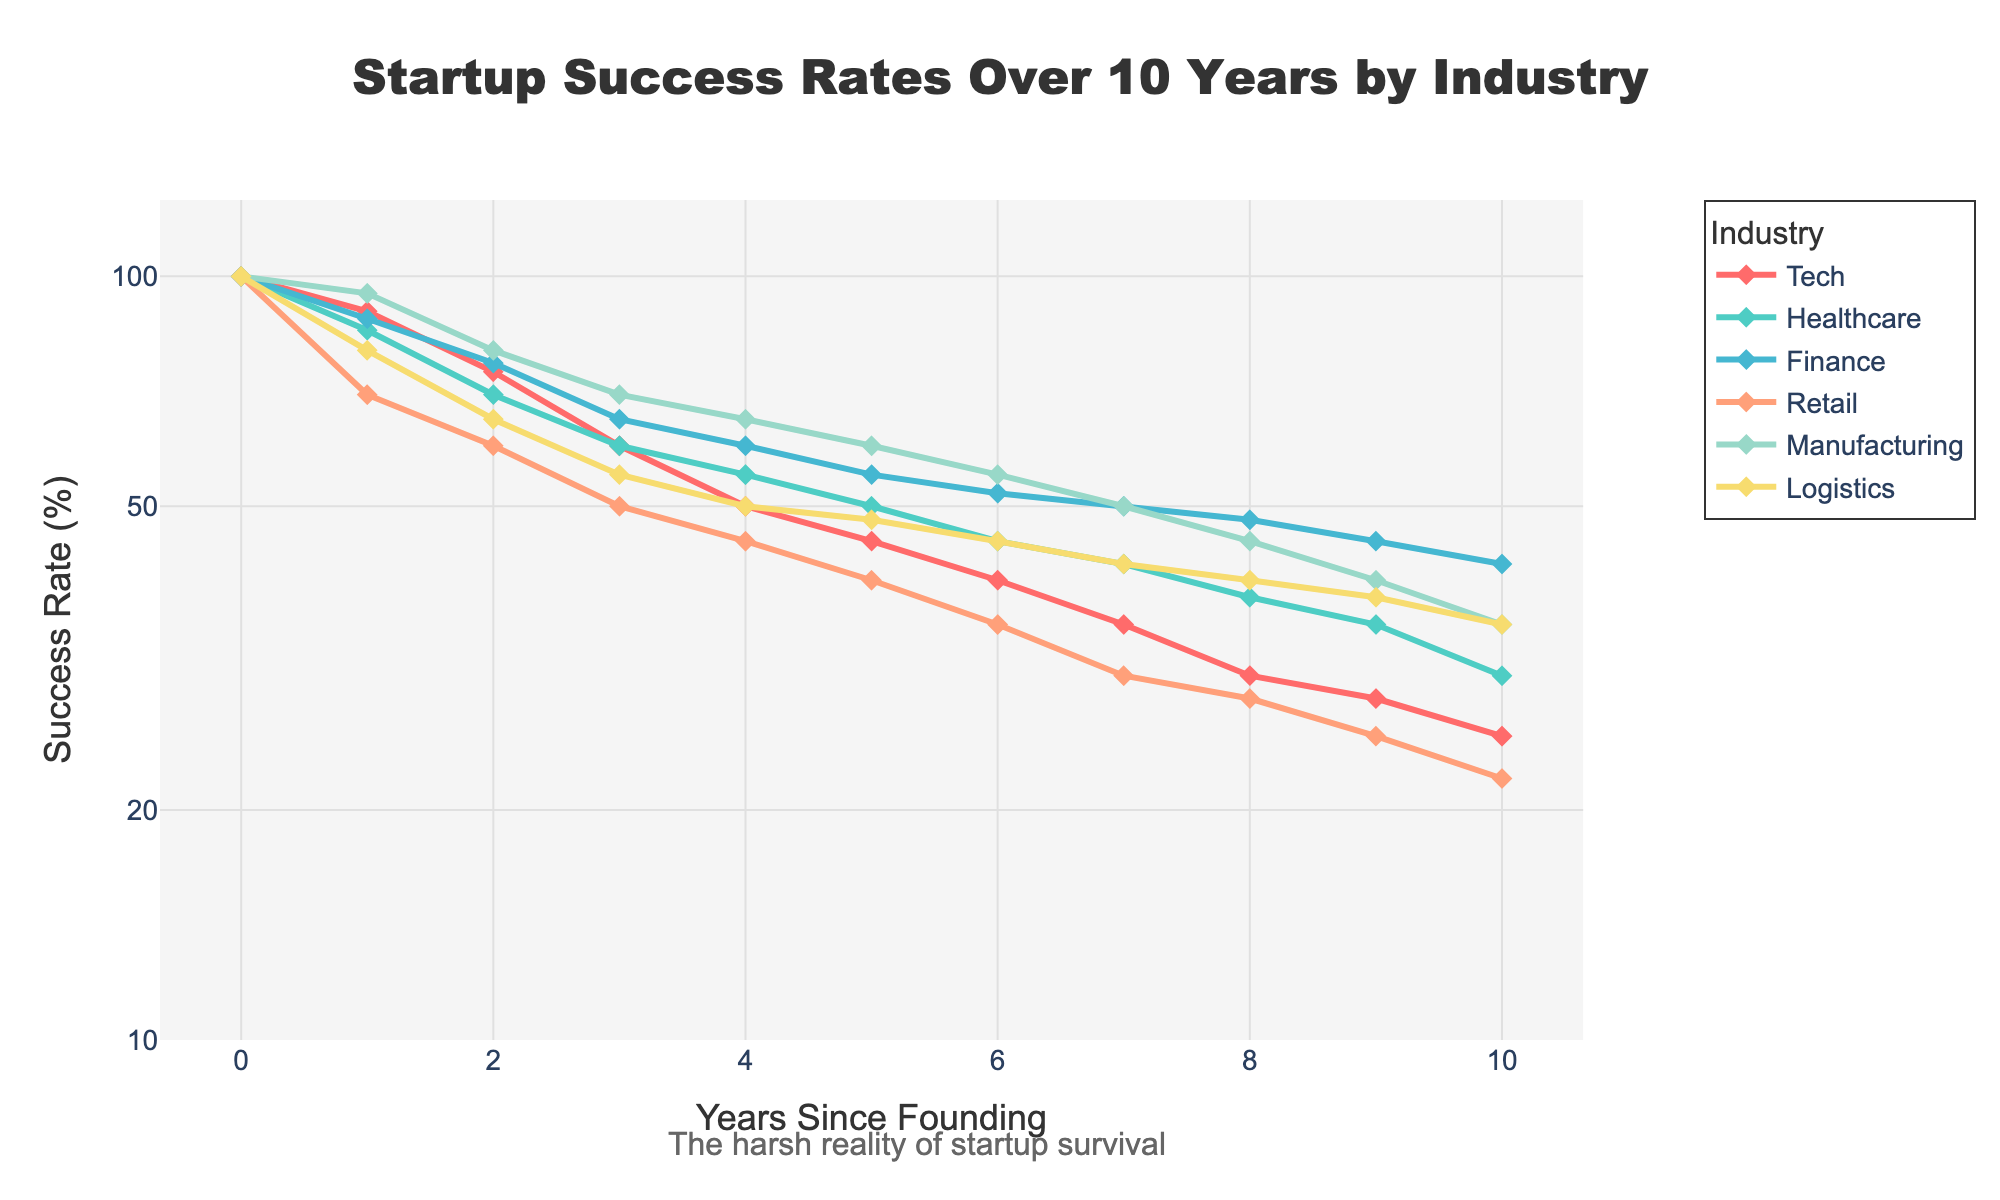1. What is the main title of the plot? The main title of the plot is prominently displayed at the top of the figure. It provides a summary of what the plot represents.
Answer: Startup Success Rates Over 10 Years by Industry 2. How does the success rate of Tech startups change over the 10-year period? To observe this trend, trace the line corresponding to the Tech industry from year 0 to year 10 on the x-axis and note the change in percentage.
Answer: Decreases from 100% to 25% 3. Which industry shows the highest success rate in year 5? Refer to the year 5 point on the x-axis, then look at all the lines to identify which one has the highest y-coordinate.
Answer: Manufacturing 4. How does the success rate of Retail compare to Logistics after 3 years? Identify both lines (Retail and Logistics) and compare their values at the 3-year mark on the x-axis.
Answer: Retail: 50%, Logistics: 55% 5. What general trend can be observed in the success rates of all industries over the given period? Look for overall patterns in the lines representing each industry from year 0 to year 10.
Answer: All industries show a decreasing trend 6. By what percentage does Finance's success rate decrease from year 2 to year 4? Note the success rates of Finance at year 2 (77%) and year 4 (60%), then calculate the percentage decrease: (77 - 60) / 77 * 100%.
Answer: 22.08% 7. Between which years does Healthcare see the most significant drop in success rate? Find the segment of the Healthcare line where the steepest decline occurs by comparing the slopes between consecutive years.
Answer: Year 0 to Year 1 8. Is there any industry that maintains a relatively steady success rate compared to others? To identify steadiness, look for the line with the least steep slopes across the years.
Answer: Manufacturing 9. Which industry experiences the fastest rate of decline in success rates initially (first 2 years)? Compare the initial segments of each industry's line from year 0 to year 2 to identify the steepest decline.
Answer: Healthcare 10. How does the success rate of Healthcare at year 10 compare to the success rate of Logistics at year 6? Identify the success rates on the graph for Healthcare at year 10 (30%) and Logistics at year 6 (45%), then compare them.
Answer: Healthcare is lower at 30% vs Logistics at 45% 